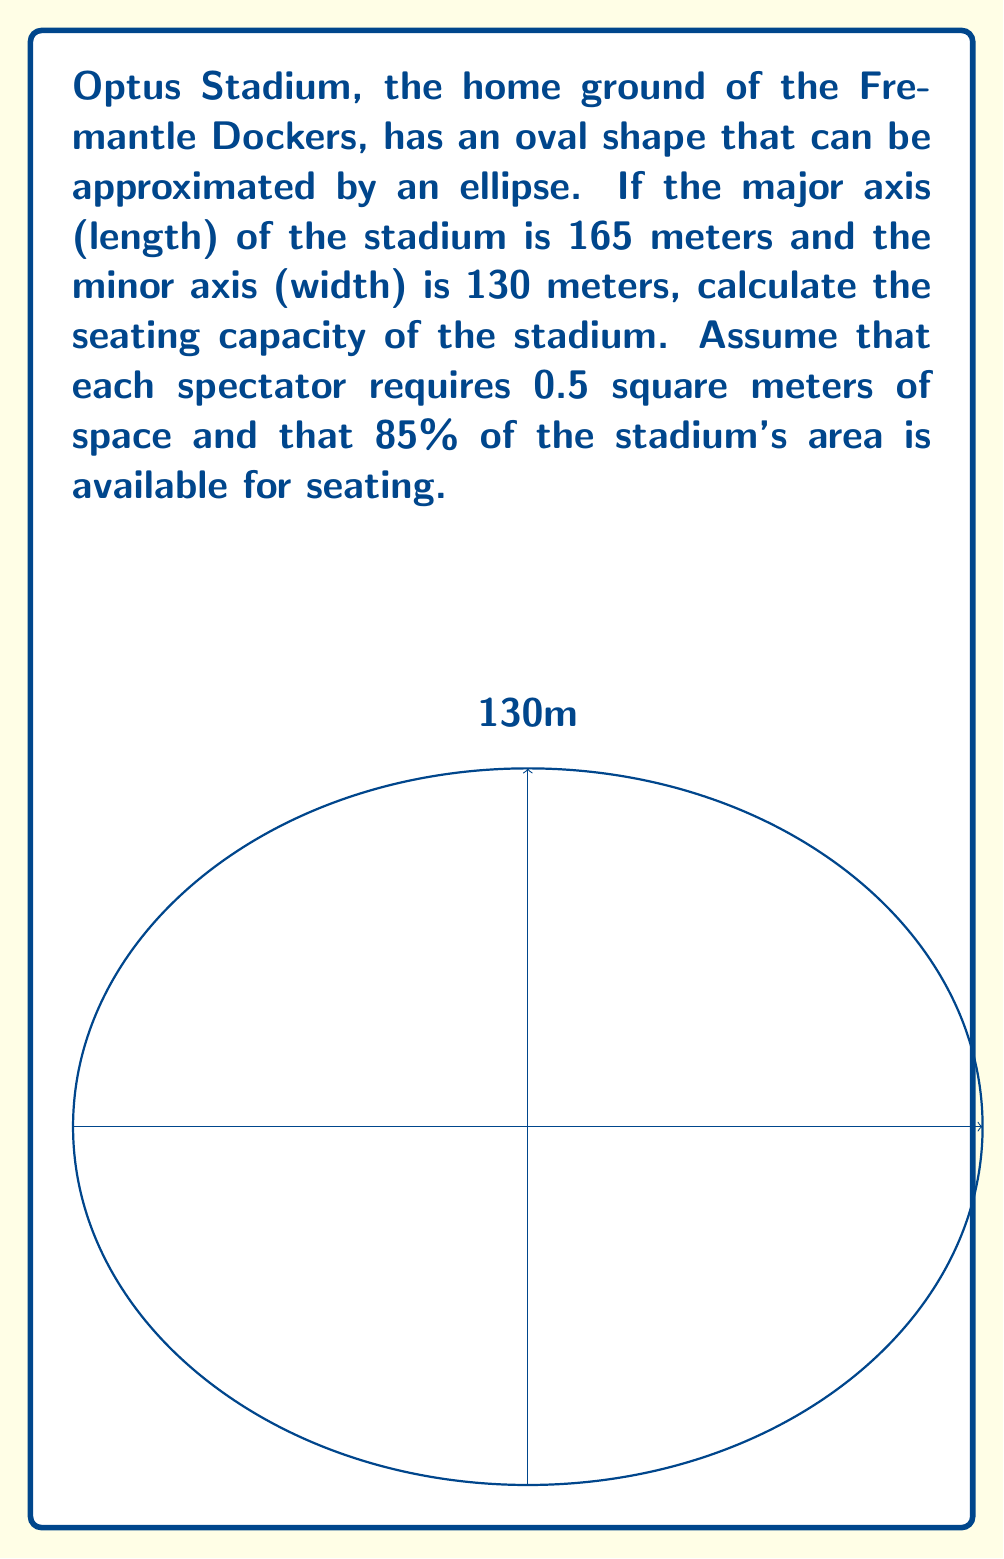Show me your answer to this math problem. Let's approach this problem step-by-step:

1) The area of an ellipse is given by the formula:
   $$A = \pi ab$$
   where $a$ and $b$ are the semi-major and semi-minor axes respectively.

2) In this case:
   $a = 165/2 = 82.5$ meters
   $b = 130/2 = 65$ meters

3) Substituting these values:
   $$A = \pi(82.5)(65) = 16,815.71 \text{ m}^2$$

4) However, only 85% of this area is available for seating:
   $$\text{Seating area} = 16,815.71 \times 0.85 = 14,293.35 \text{ m}^2$$

5) Each spectator requires 0.5 square meters, so the number of spectators that can be seated is:
   $$\text{Number of spectators} = \frac{14,293.35 \text{ m}^2}{0.5 \text{ m}^2/\text{person}} = 28,586.7$$

6) Rounding down to the nearest whole number (as we can't have a fraction of a person):
   $$\text{Seating capacity} = 28,586 \text{ people}$$
Answer: 28,586 people 